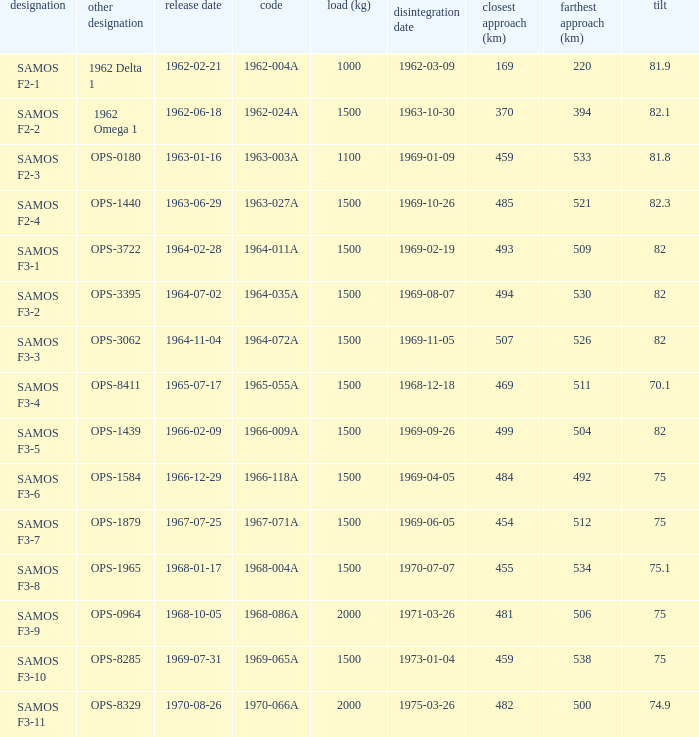What was the maximum perigee on 1969-01-09? 459.0. 